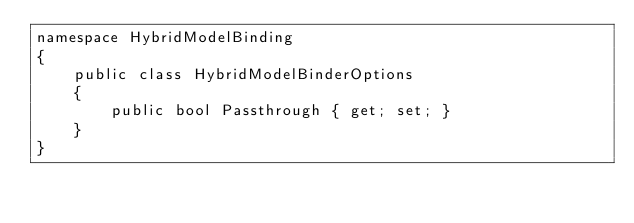Convert code to text. <code><loc_0><loc_0><loc_500><loc_500><_C#_>namespace HybridModelBinding
{
    public class HybridModelBinderOptions
    {
        public bool Passthrough { get; set; }
    }
}</code> 